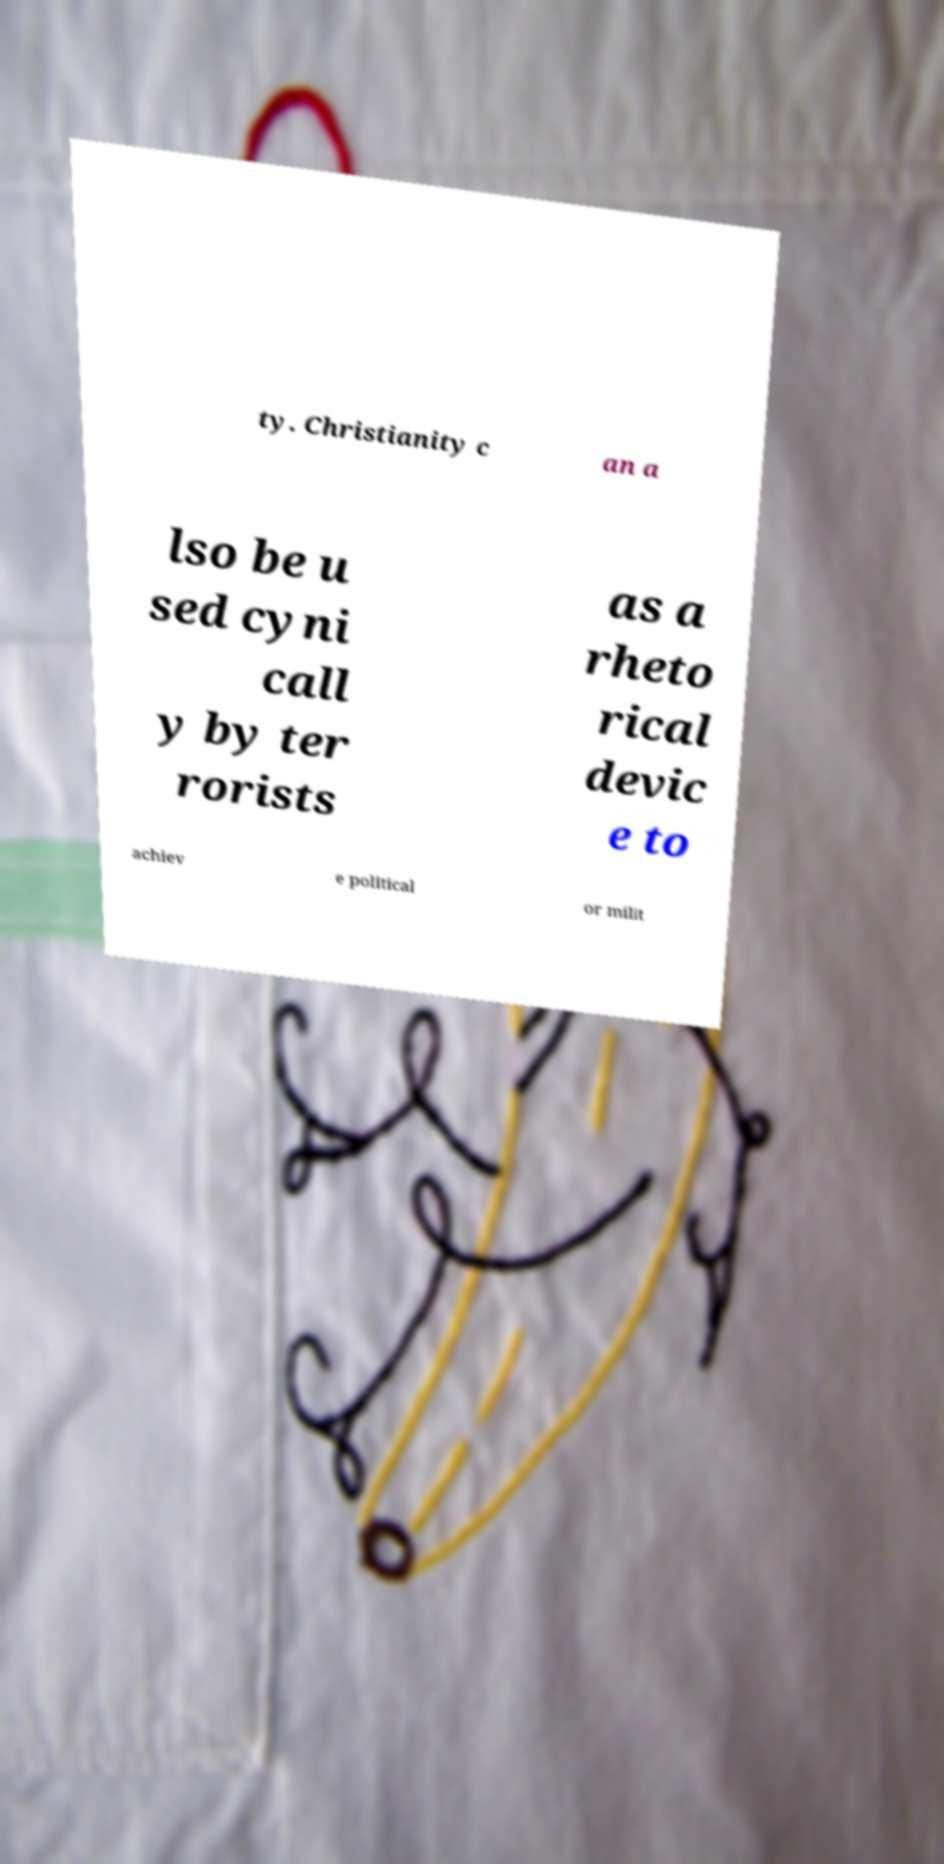For documentation purposes, I need the text within this image transcribed. Could you provide that? ty. Christianity c an a lso be u sed cyni call y by ter rorists as a rheto rical devic e to achiev e political or milit 